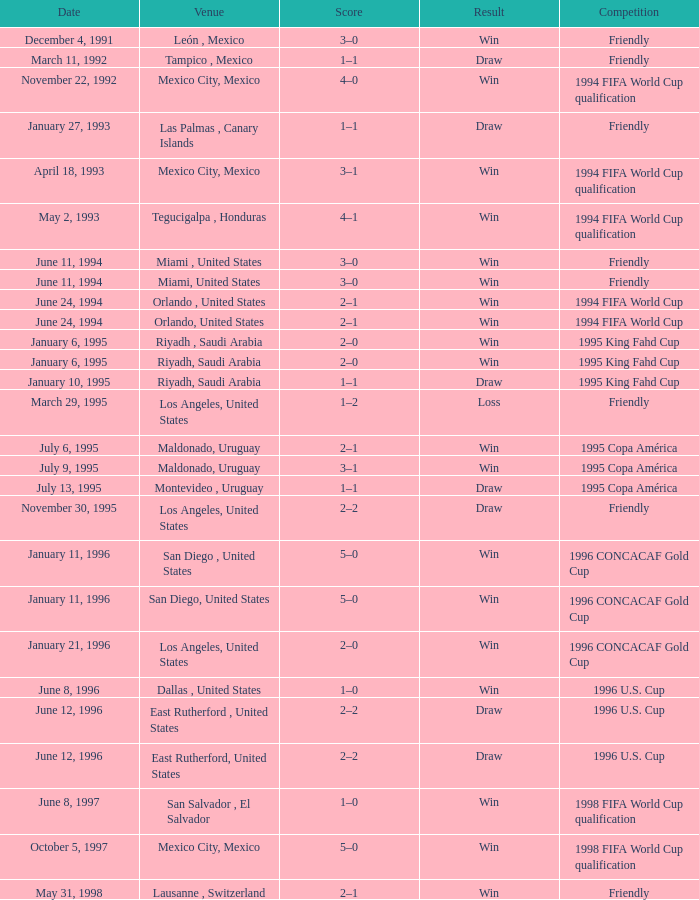Give me the full table as a dictionary. {'header': ['Date', 'Venue', 'Score', 'Result', 'Competition'], 'rows': [['December 4, 1991', 'León , Mexico', '3–0', 'Win', 'Friendly'], ['March 11, 1992', 'Tampico , Mexico', '1–1', 'Draw', 'Friendly'], ['November 22, 1992', 'Mexico City, Mexico', '4–0', 'Win', '1994 FIFA World Cup qualification'], ['January 27, 1993', 'Las Palmas , Canary Islands', '1–1', 'Draw', 'Friendly'], ['April 18, 1993', 'Mexico City, Mexico', '3–1', 'Win', '1994 FIFA World Cup qualification'], ['May 2, 1993', 'Tegucigalpa , Honduras', '4–1', 'Win', '1994 FIFA World Cup qualification'], ['June 11, 1994', 'Miami , United States', '3–0', 'Win', 'Friendly'], ['June 11, 1994', 'Miami, United States', '3–0', 'Win', 'Friendly'], ['June 24, 1994', 'Orlando , United States', '2–1', 'Win', '1994 FIFA World Cup'], ['June 24, 1994', 'Orlando, United States', '2–1', 'Win', '1994 FIFA World Cup'], ['January 6, 1995', 'Riyadh , Saudi Arabia', '2–0', 'Win', '1995 King Fahd Cup'], ['January 6, 1995', 'Riyadh, Saudi Arabia', '2–0', 'Win', '1995 King Fahd Cup'], ['January 10, 1995', 'Riyadh, Saudi Arabia', '1–1', 'Draw', '1995 King Fahd Cup'], ['March 29, 1995', 'Los Angeles, United States', '1–2', 'Loss', 'Friendly'], ['July 6, 1995', 'Maldonado, Uruguay', '2–1', 'Win', '1995 Copa América'], ['July 9, 1995', 'Maldonado, Uruguay', '3–1', 'Win', '1995 Copa América'], ['July 13, 1995', 'Montevideo , Uruguay', '1–1', 'Draw', '1995 Copa América'], ['November 30, 1995', 'Los Angeles, United States', '2–2', 'Draw', 'Friendly'], ['January 11, 1996', 'San Diego , United States', '5–0', 'Win', '1996 CONCACAF Gold Cup'], ['January 11, 1996', 'San Diego, United States', '5–0', 'Win', '1996 CONCACAF Gold Cup'], ['January 21, 1996', 'Los Angeles, United States', '2–0', 'Win', '1996 CONCACAF Gold Cup'], ['June 8, 1996', 'Dallas , United States', '1–0', 'Win', '1996 U.S. Cup'], ['June 12, 1996', 'East Rutherford , United States', '2–2', 'Draw', '1996 U.S. Cup'], ['June 12, 1996', 'East Rutherford, United States', '2–2', 'Draw', '1996 U.S. Cup'], ['June 8, 1997', 'San Salvador , El Salvador', '1–0', 'Win', '1998 FIFA World Cup qualification'], ['October 5, 1997', 'Mexico City, Mexico', '5–0', 'Win', '1998 FIFA World Cup qualification'], ['May 31, 1998', 'Lausanne , Switzerland', '2–1', 'Win', 'Friendly']]} What is the outcome if the date is "june 11, 1994" and the venue is "miami, united states"? Win, Win. 